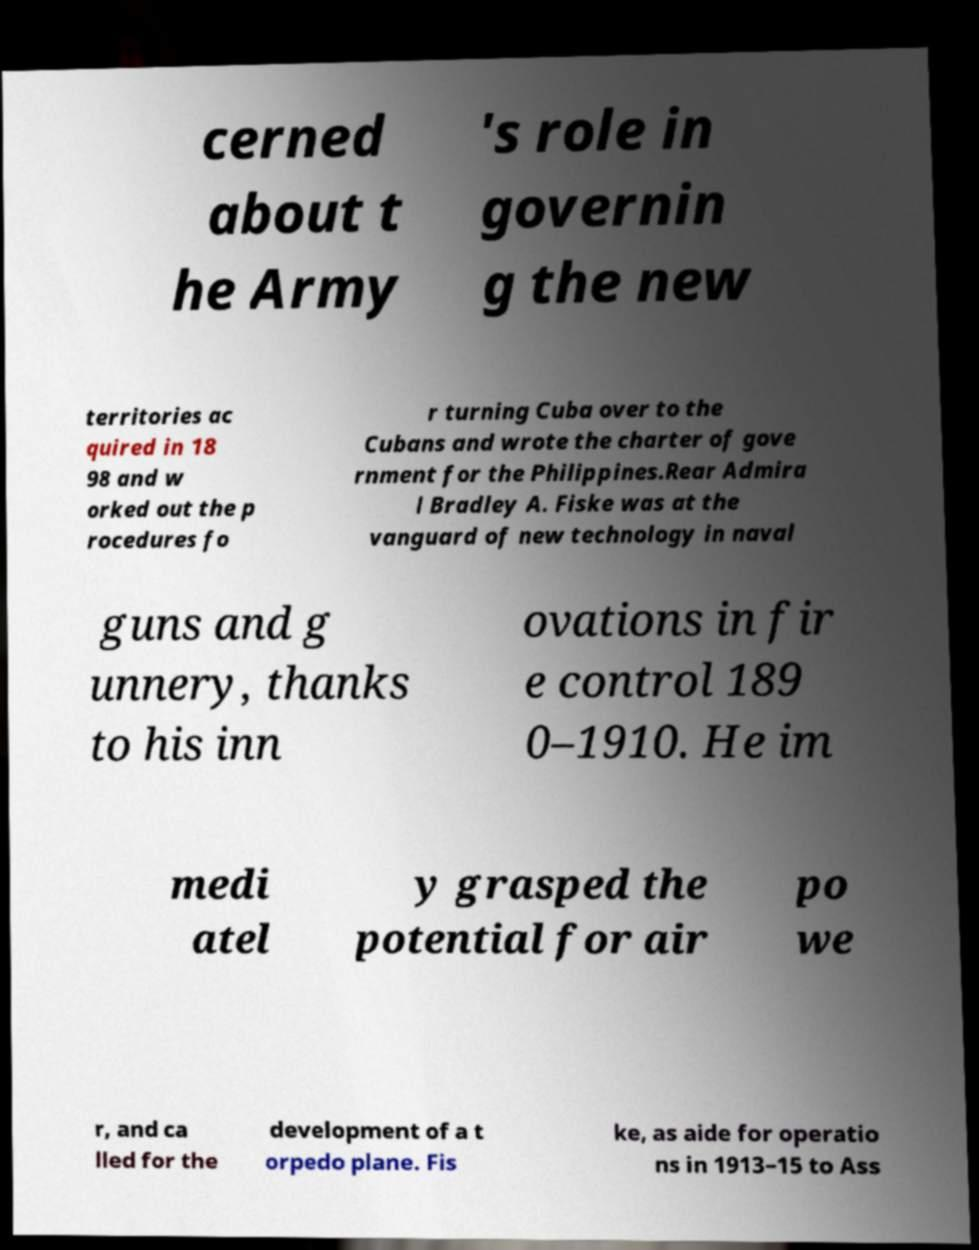Please identify and transcribe the text found in this image. cerned about t he Army 's role in governin g the new territories ac quired in 18 98 and w orked out the p rocedures fo r turning Cuba over to the Cubans and wrote the charter of gove rnment for the Philippines.Rear Admira l Bradley A. Fiske was at the vanguard of new technology in naval guns and g unnery, thanks to his inn ovations in fir e control 189 0–1910. He im medi atel y grasped the potential for air po we r, and ca lled for the development of a t orpedo plane. Fis ke, as aide for operatio ns in 1913–15 to Ass 